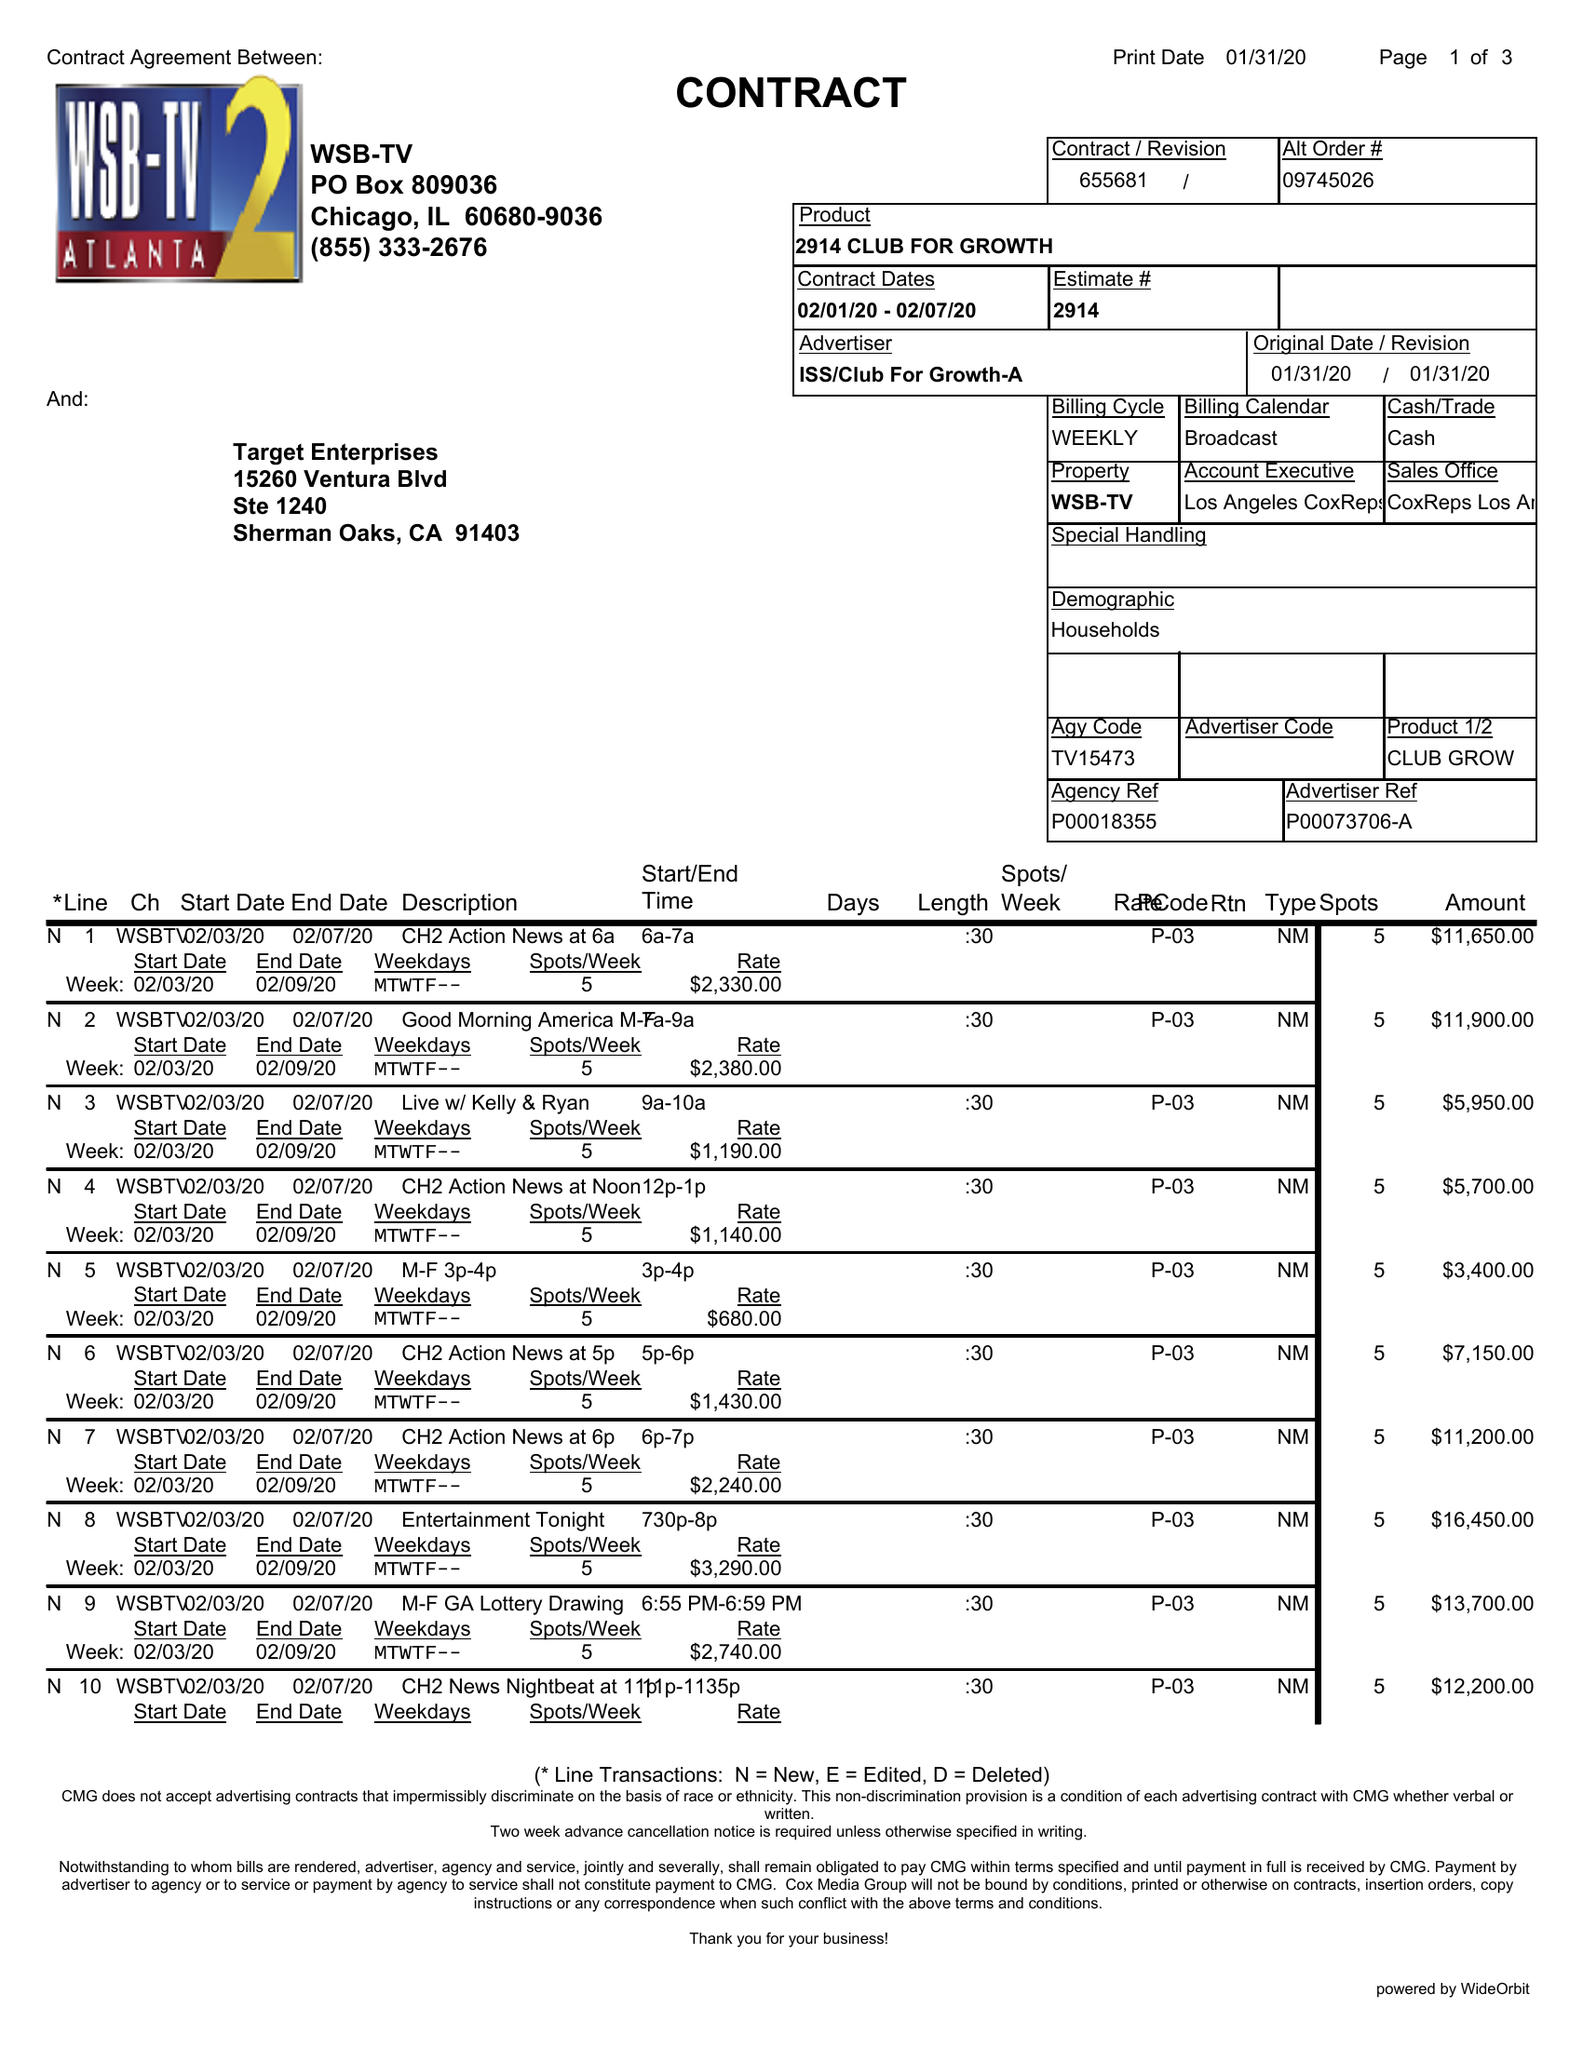What is the value for the flight_from?
Answer the question using a single word or phrase. 02/01/20 